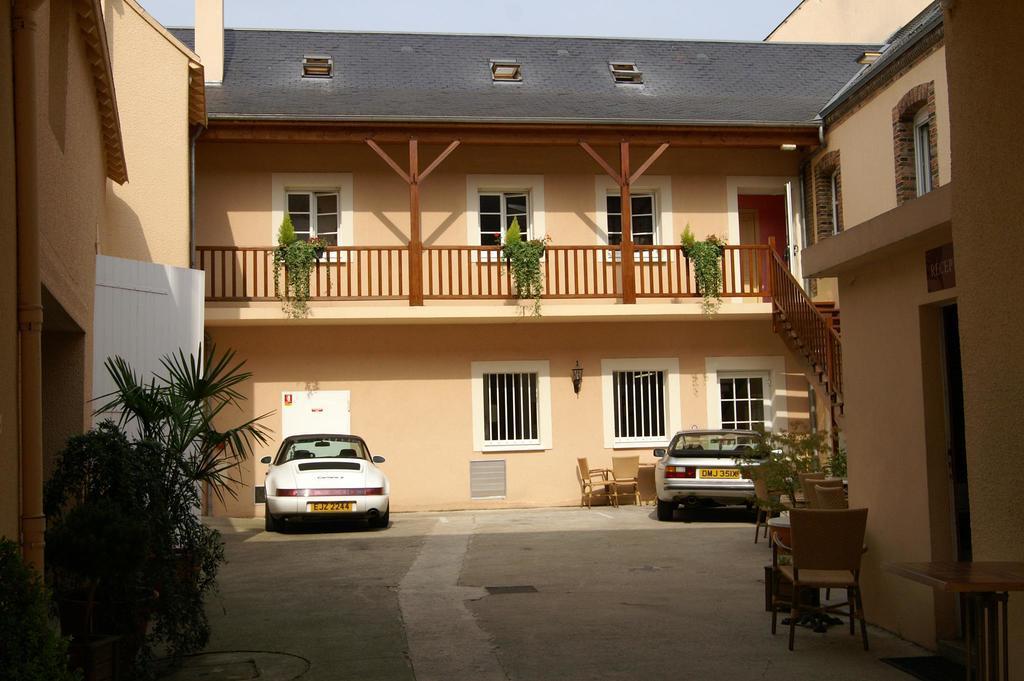How would you summarize this image in a sentence or two? In this picture its a sunny day , there are two buildings and two cars parked. There is a small tree at the left side in the beginning and also trees are also located on the wooden shaft in the building. There are also three ventilators on the roof of the building. Many chairs located on the ground level. 